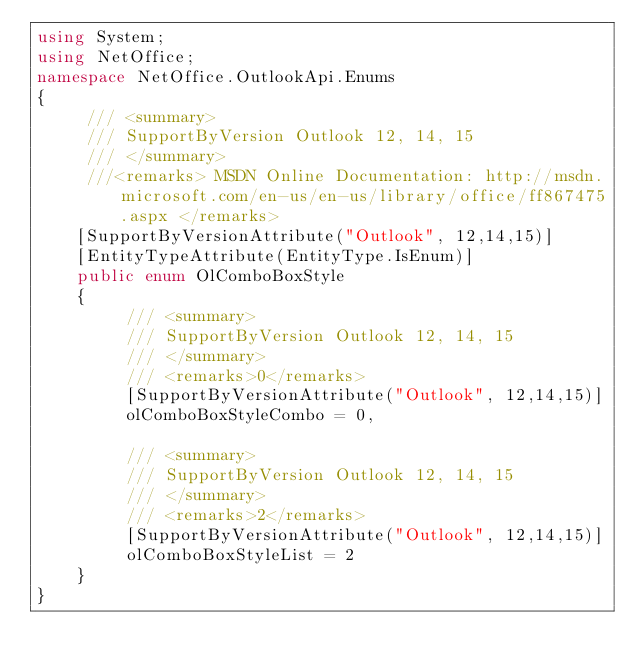<code> <loc_0><loc_0><loc_500><loc_500><_C#_>using System;
using NetOffice;
namespace NetOffice.OutlookApi.Enums
{
	 /// <summary>
	 /// SupportByVersion Outlook 12, 14, 15
	 /// </summary>
	 ///<remarks> MSDN Online Documentation: http://msdn.microsoft.com/en-us/en-us/library/office/ff867475.aspx </remarks>
	[SupportByVersionAttribute("Outlook", 12,14,15)]
	[EntityTypeAttribute(EntityType.IsEnum)]
	public enum OlComboBoxStyle
	{
		 /// <summary>
		 /// SupportByVersion Outlook 12, 14, 15
		 /// </summary>
		 /// <remarks>0</remarks>
		 [SupportByVersionAttribute("Outlook", 12,14,15)]
		 olComboBoxStyleCombo = 0,

		 /// <summary>
		 /// SupportByVersion Outlook 12, 14, 15
		 /// </summary>
		 /// <remarks>2</remarks>
		 [SupportByVersionAttribute("Outlook", 12,14,15)]
		 olComboBoxStyleList = 2
	}
}</code> 